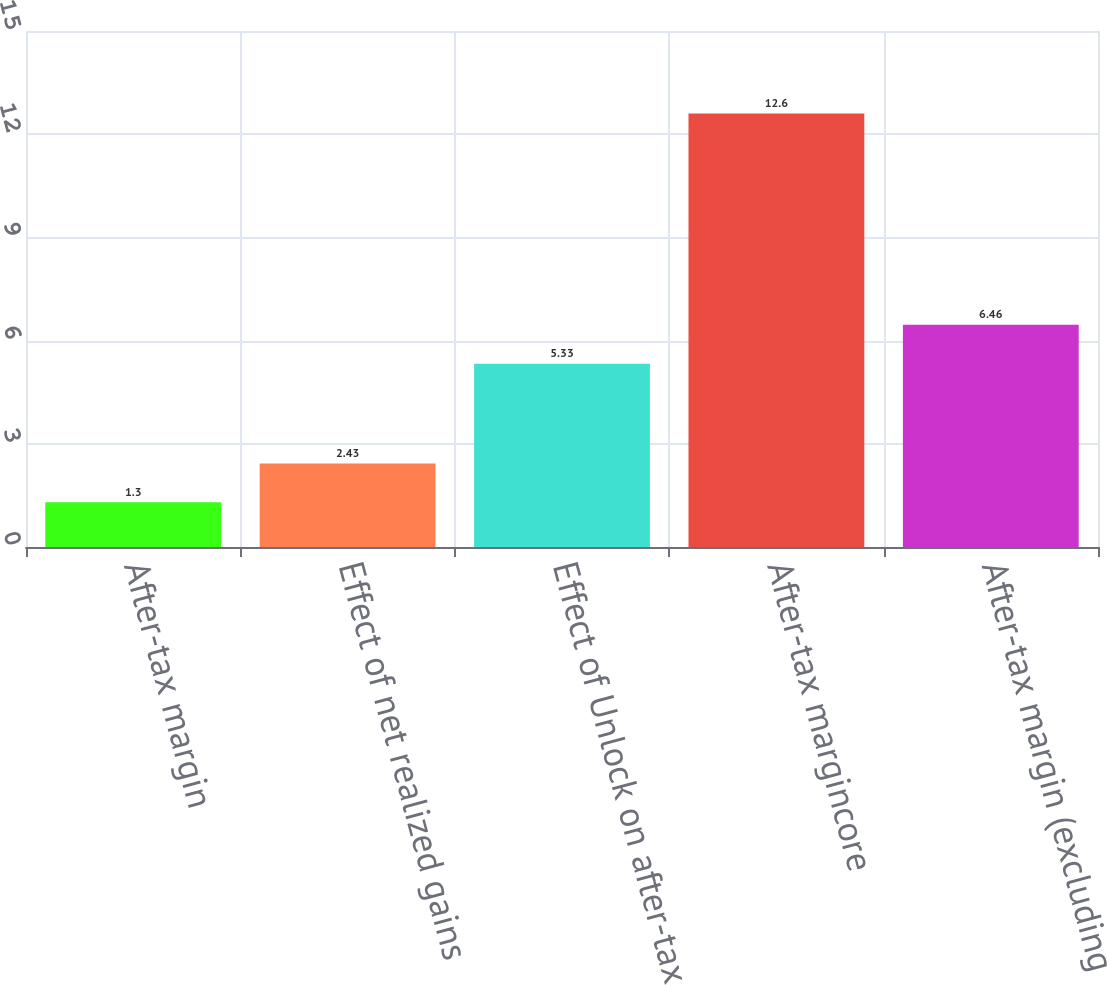Convert chart to OTSL. <chart><loc_0><loc_0><loc_500><loc_500><bar_chart><fcel>After-tax margin<fcel>Effect of net realized gains<fcel>Effect of Unlock on after-tax<fcel>After-tax margincore<fcel>After-tax margin (excluding<nl><fcel>1.3<fcel>2.43<fcel>5.33<fcel>12.6<fcel>6.46<nl></chart> 